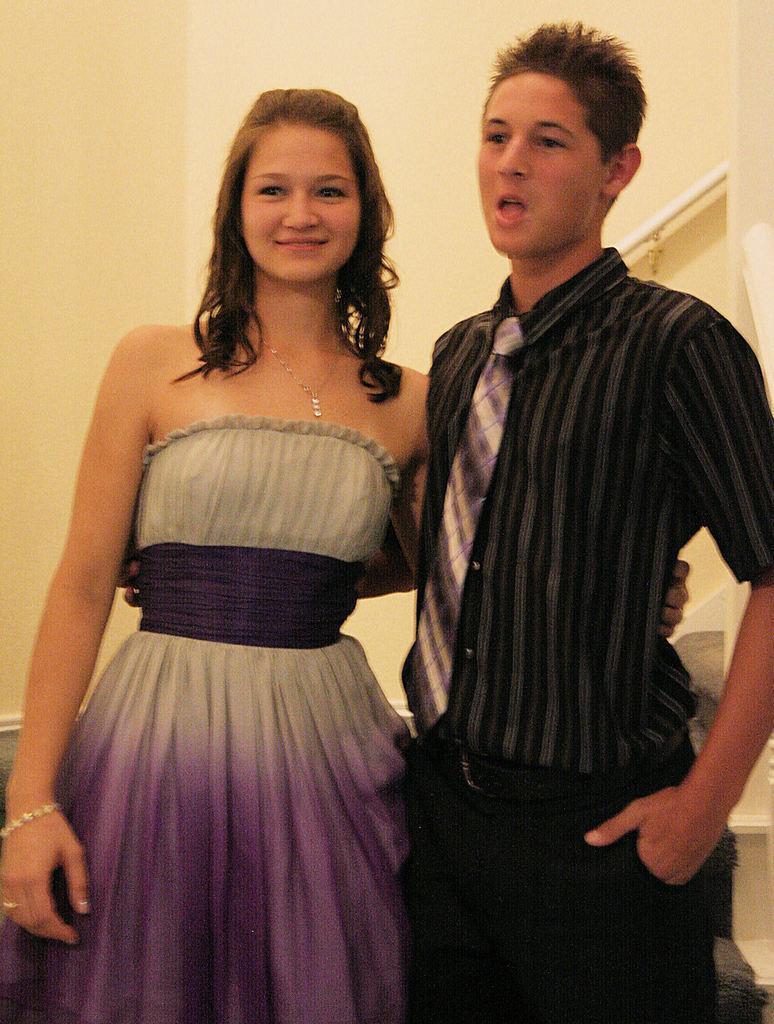Please provide a concise description of this image. In this picture I can see there is a boy and a girl standing, the boy is wearing a black shirt, pant and a tie. The girl standing beside the boy is wearing a grey and purple dress and there are stairs and a wall in the backdrop. 